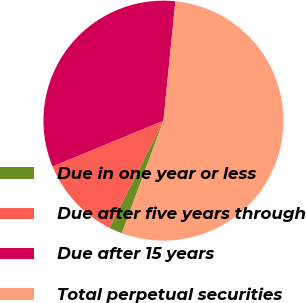Convert chart to OTSL. <chart><loc_0><loc_0><loc_500><loc_500><pie_chart><fcel>Due in one year or less<fcel>Due after five years through<fcel>Due after 15 years<fcel>Total perpetual securities<nl><fcel>1.79%<fcel>11.35%<fcel>32.82%<fcel>54.04%<nl></chart> 